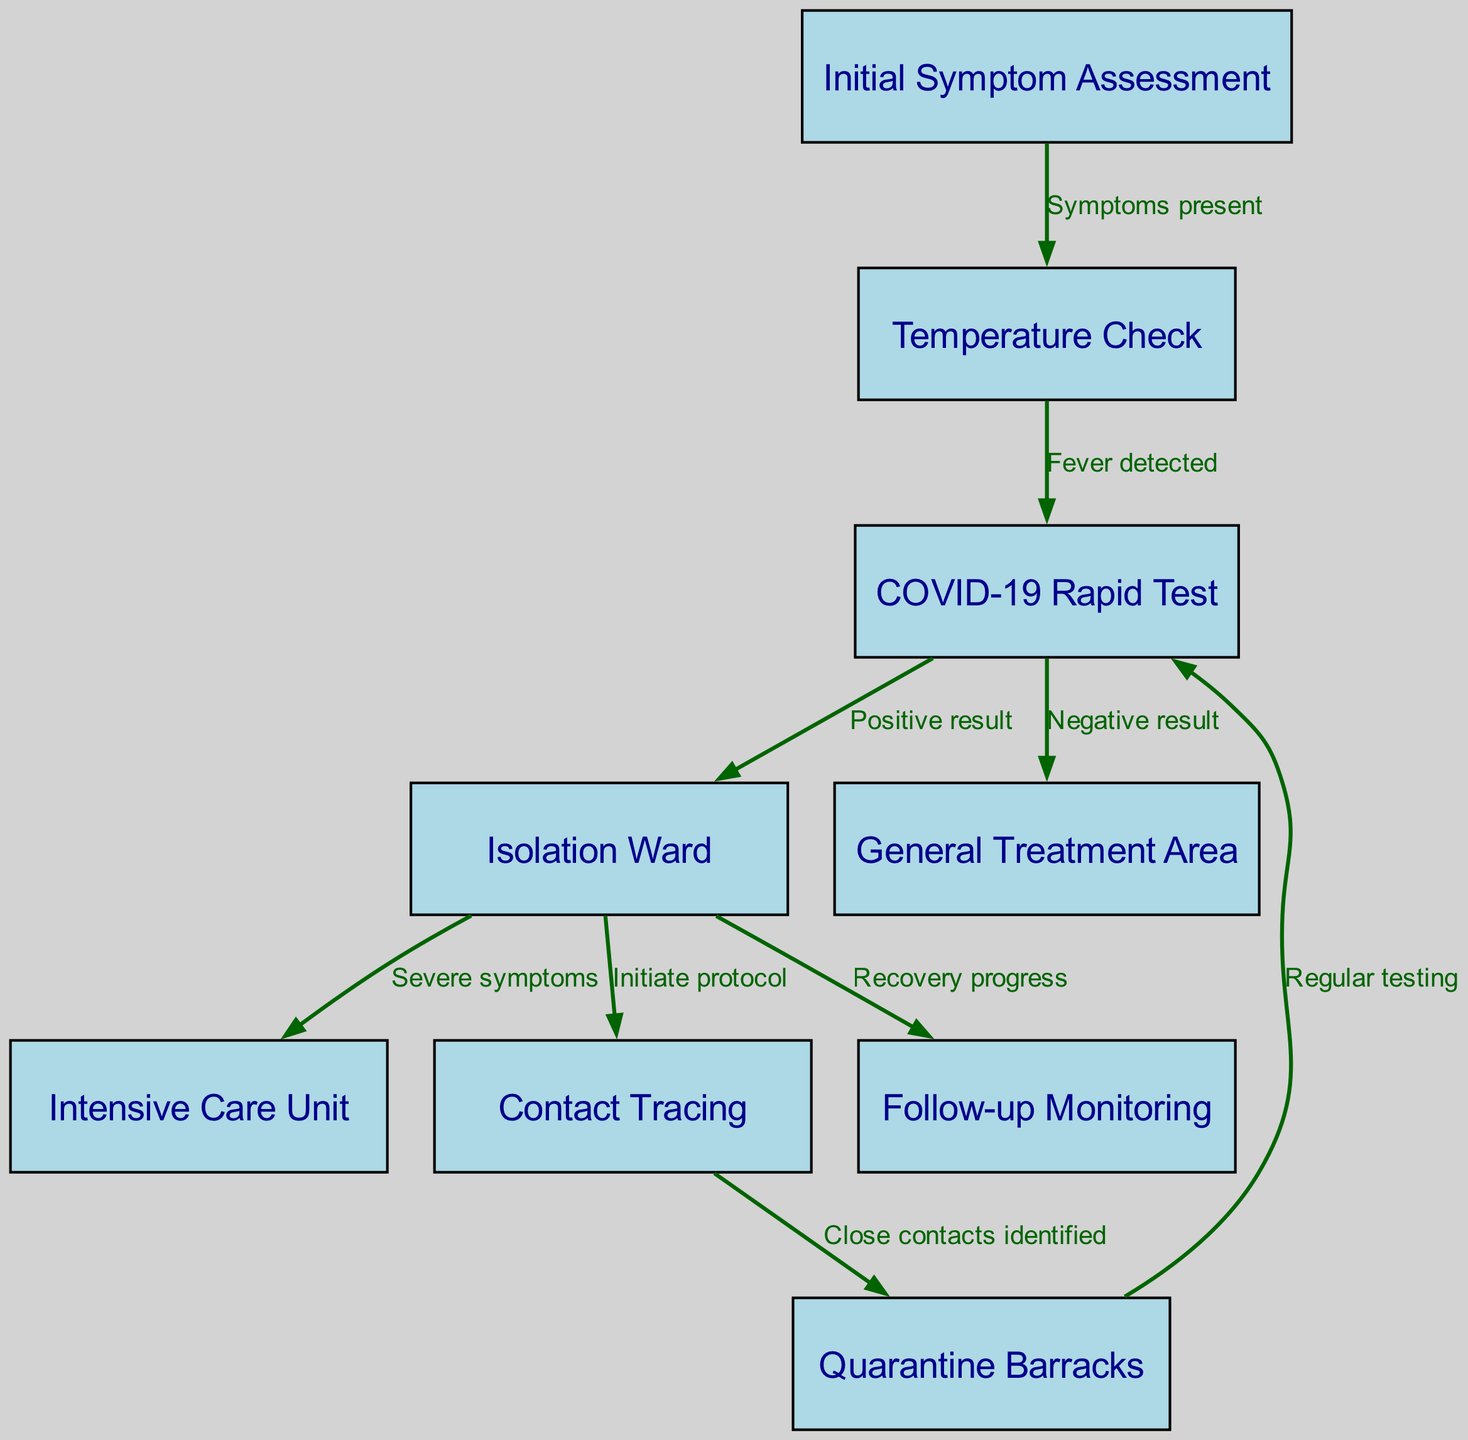What is the first step in the triaging process? The diagram shows "Initial Symptom Assessment" as the starting point of the process. This node is where the assessment begins for soldiers presenting symptoms.
Answer: Initial Symptom Assessment How many total nodes are present in the diagram? By counting all the nodes listed in the diagram, we can observe there are nine nodes representing different stages of the triage process.
Answer: 9 What does a positive result from the COVID-19 Rapid Test lead to? According to the diagram, a positive result from the "COVID-19 Rapid Test" directs the flow to the "Isolation Ward," indicating that the soldier must be isolated for further care.
Answer: Isolation Ward What is the outcome if a soldier has severe symptoms while in the Isolation Ward? The diagram indicates that from the "Isolation Ward," soldiers with severe symptoms are moved to the "Intensive Care Unit" for more advanced care.
Answer: Intensive Care Unit What later action is initiated when close contacts are identified? From the "Contact Tracing" node in the diagram, the next step is to proceed to "Quarantine Barracks," highlighting the protocol to quarantine identified contacts.
Answer: Quarantine Barracks After a negative result from the COVID-19 Rapid Test, where does the process lead? The diagram shows that if the result is negative, the process moves to the "General Treatment Area," indicating that the soldier does not need to be isolated.
Answer: General Treatment Area What node is reached after the "Isolation Ward" if recovery progress is noted? According to the diagram, successful recovery progress from the "Isolation Ward" results in flow to "Follow-up Monitoring," allowing for ongoing assessment after recovery.
Answer: Follow-up Monitoring How does one return to the COVID-19 Rapid Test from Quarantine Barracks? The diagram details that from the "Quarantine Barracks," regular testing leads back to the "COVID-19 Rapid Test," ensuring ongoing vigilance for potential infections.
Answer: COVID-19 Rapid Test What visual element connects contacts identified to the next action in the diagram? The arrow represents the directed flow from the "Contact Tracing" node to "Quarantine Barracks," indicating movement based on identifying close contacts.
Answer: Arrow 